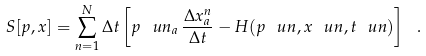<formula> <loc_0><loc_0><loc_500><loc_500>S [ p , x ] = \sum _ { n = 1 } ^ { N } \Delta t \left [ p ^ { \ } u n _ { a } \, \frac { \Delta x ^ { n } _ { a } } { \Delta t } - H ( p ^ { \ } u n , x ^ { \ } u n , t ^ { \ } u n ) \right ] \ .</formula> 